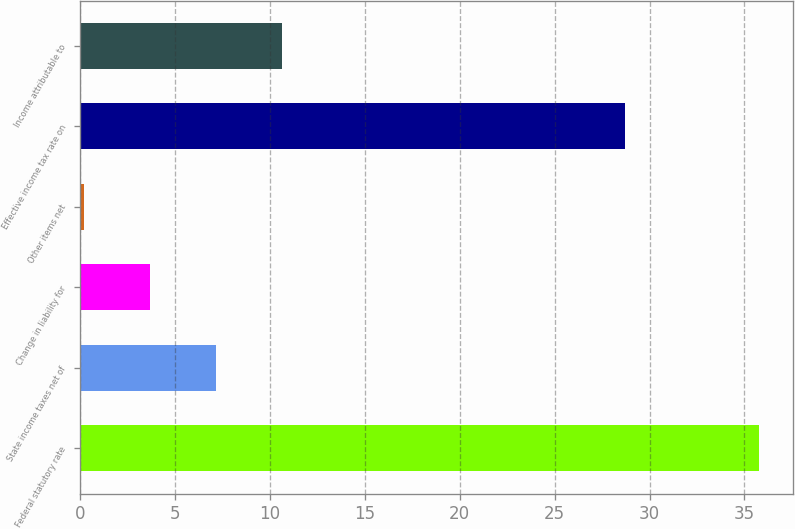Convert chart. <chart><loc_0><loc_0><loc_500><loc_500><bar_chart><fcel>Federal statutory rate<fcel>State income taxes net of<fcel>Change in liability for<fcel>Other items net<fcel>Effective income tax rate on<fcel>Income attributable to<nl><fcel>35.78<fcel>7.16<fcel>3.68<fcel>0.2<fcel>28.7<fcel>10.64<nl></chart> 